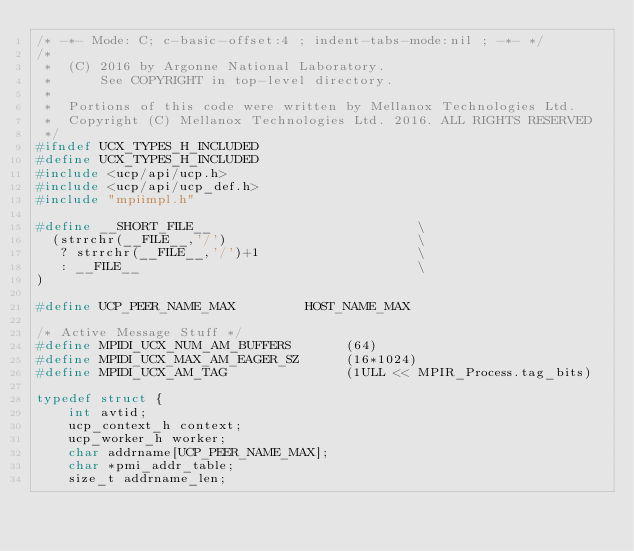Convert code to text. <code><loc_0><loc_0><loc_500><loc_500><_C_>/* -*- Mode: C; c-basic-offset:4 ; indent-tabs-mode:nil ; -*- */
/*
 *  (C) 2016 by Argonne National Laboratory.
 *      See COPYRIGHT in top-level directory.
 *
 *  Portions of this code were written by Mellanox Technologies Ltd.
 *  Copyright (C) Mellanox Technologies Ltd. 2016. ALL RIGHTS RESERVED
 */
#ifndef UCX_TYPES_H_INCLUDED
#define UCX_TYPES_H_INCLUDED
#include <ucp/api/ucp.h>
#include <ucp/api/ucp_def.h>
#include "mpiimpl.h"

#define __SHORT_FILE__                          \
  (strrchr(__FILE__,'/')                        \
   ? strrchr(__FILE__,'/')+1                    \
   : __FILE__                                   \
)

#define UCP_PEER_NAME_MAX         HOST_NAME_MAX

/* Active Message Stuff */
#define MPIDI_UCX_NUM_AM_BUFFERS       (64)
#define MPIDI_UCX_MAX_AM_EAGER_SZ      (16*1024)
#define MPIDI_UCX_AM_TAG               (1ULL << MPIR_Process.tag_bits)

typedef struct {
    int avtid;
    ucp_context_h context;
    ucp_worker_h worker;
    char addrname[UCP_PEER_NAME_MAX];
    char *pmi_addr_table;
    size_t addrname_len;</code> 